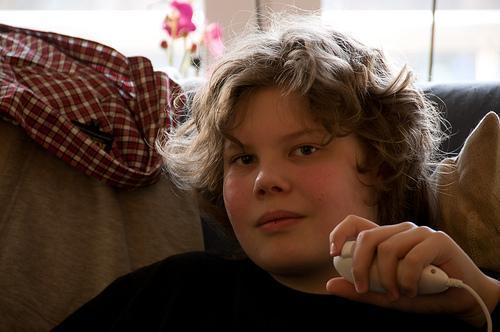How many elephants are there?
Give a very brief answer. 0. 